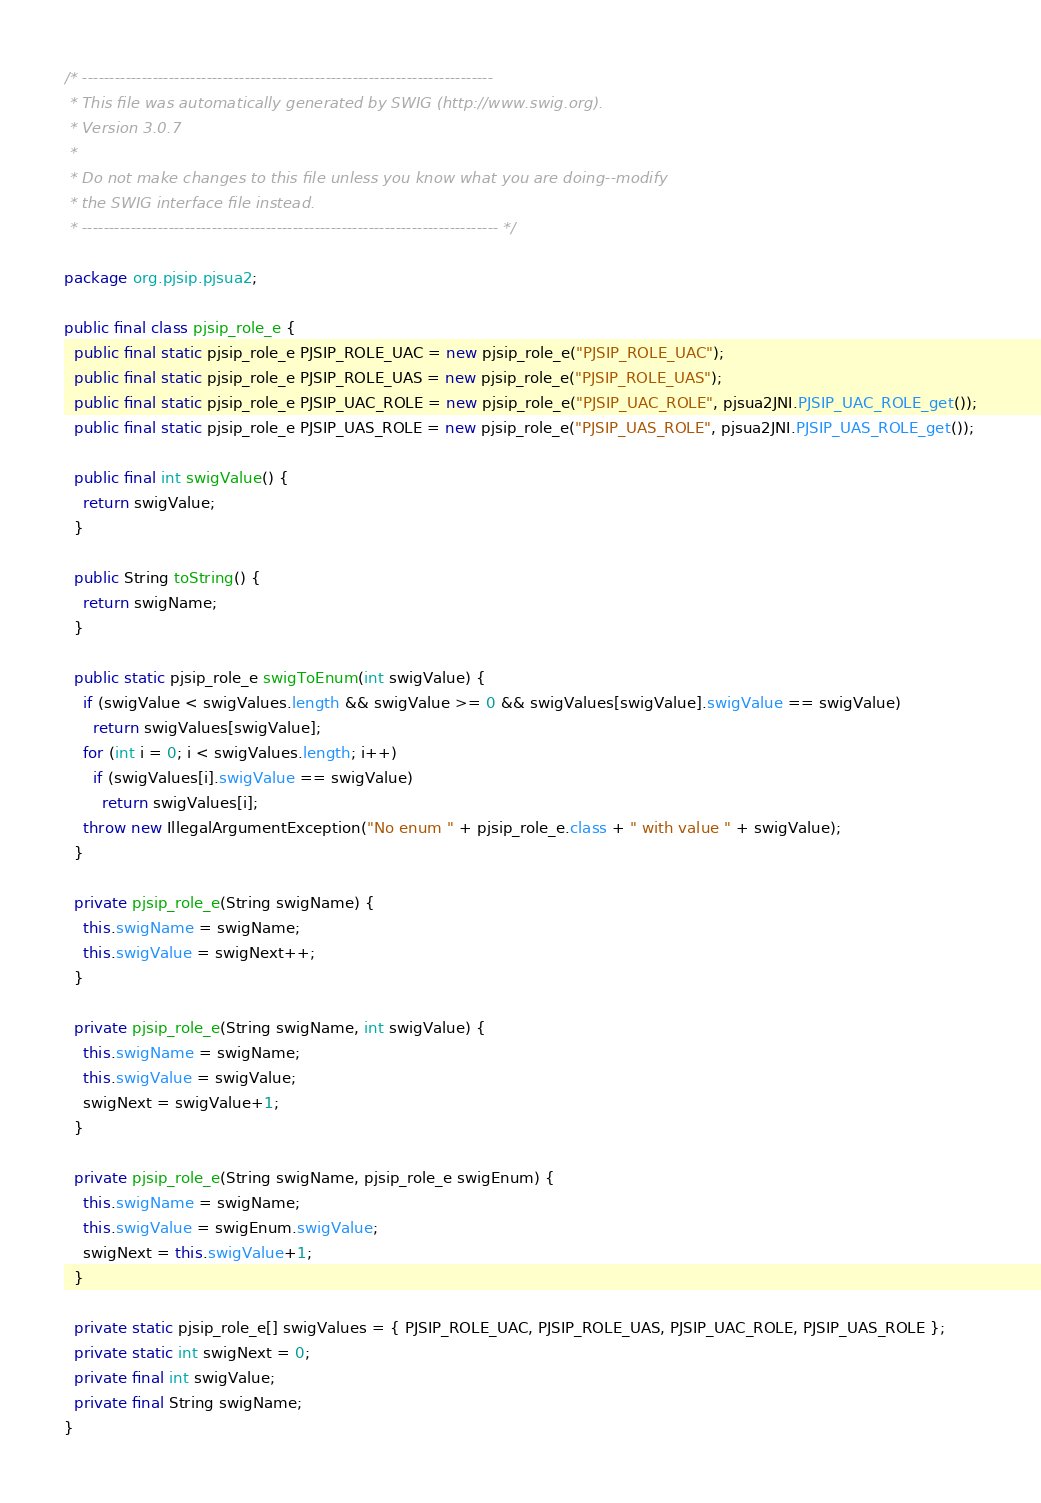Convert code to text. <code><loc_0><loc_0><loc_500><loc_500><_Java_>/* ----------------------------------------------------------------------------
 * This file was automatically generated by SWIG (http://www.swig.org).
 * Version 3.0.7
 *
 * Do not make changes to this file unless you know what you are doing--modify
 * the SWIG interface file instead.
 * ----------------------------------------------------------------------------- */

package org.pjsip.pjsua2;

public final class pjsip_role_e {
  public final static pjsip_role_e PJSIP_ROLE_UAC = new pjsip_role_e("PJSIP_ROLE_UAC");
  public final static pjsip_role_e PJSIP_ROLE_UAS = new pjsip_role_e("PJSIP_ROLE_UAS");
  public final static pjsip_role_e PJSIP_UAC_ROLE = new pjsip_role_e("PJSIP_UAC_ROLE", pjsua2JNI.PJSIP_UAC_ROLE_get());
  public final static pjsip_role_e PJSIP_UAS_ROLE = new pjsip_role_e("PJSIP_UAS_ROLE", pjsua2JNI.PJSIP_UAS_ROLE_get());

  public final int swigValue() {
    return swigValue;
  }

  public String toString() {
    return swigName;
  }

  public static pjsip_role_e swigToEnum(int swigValue) {
    if (swigValue < swigValues.length && swigValue >= 0 && swigValues[swigValue].swigValue == swigValue)
      return swigValues[swigValue];
    for (int i = 0; i < swigValues.length; i++)
      if (swigValues[i].swigValue == swigValue)
        return swigValues[i];
    throw new IllegalArgumentException("No enum " + pjsip_role_e.class + " with value " + swigValue);
  }

  private pjsip_role_e(String swigName) {
    this.swigName = swigName;
    this.swigValue = swigNext++;
  }

  private pjsip_role_e(String swigName, int swigValue) {
    this.swigName = swigName;
    this.swigValue = swigValue;
    swigNext = swigValue+1;
  }

  private pjsip_role_e(String swigName, pjsip_role_e swigEnum) {
    this.swigName = swigName;
    this.swigValue = swigEnum.swigValue;
    swigNext = this.swigValue+1;
  }

  private static pjsip_role_e[] swigValues = { PJSIP_ROLE_UAC, PJSIP_ROLE_UAS, PJSIP_UAC_ROLE, PJSIP_UAS_ROLE };
  private static int swigNext = 0;
  private final int swigValue;
  private final String swigName;
}

</code> 